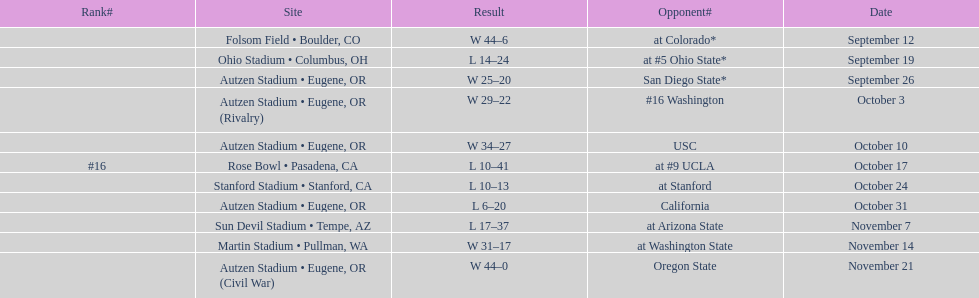What is the count of away games? 6. 